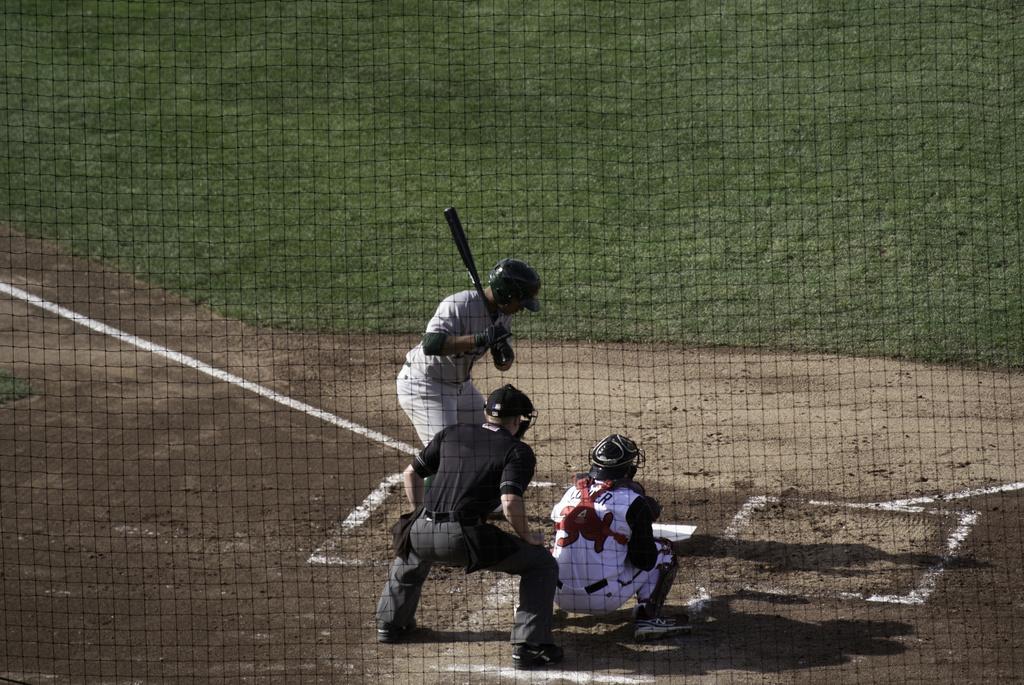Describe this image in one or two sentences. This picture might be taken inside the room. In this image, we can see a net fence. In the middle of the image, we can see three people, in that two men are in squat position and one man is holding a bat in his hand. In the background, we can see a grass. 